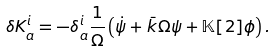<formula> <loc_0><loc_0><loc_500><loc_500>\delta K ^ { i } _ { a } = - \delta ^ { i } _ { a } \frac { 1 } { \Omega } \left ( \dot { \psi } + \bar { k } \Omega \psi + \mathbb { K } [ 2 ] \phi \right ) .</formula> 